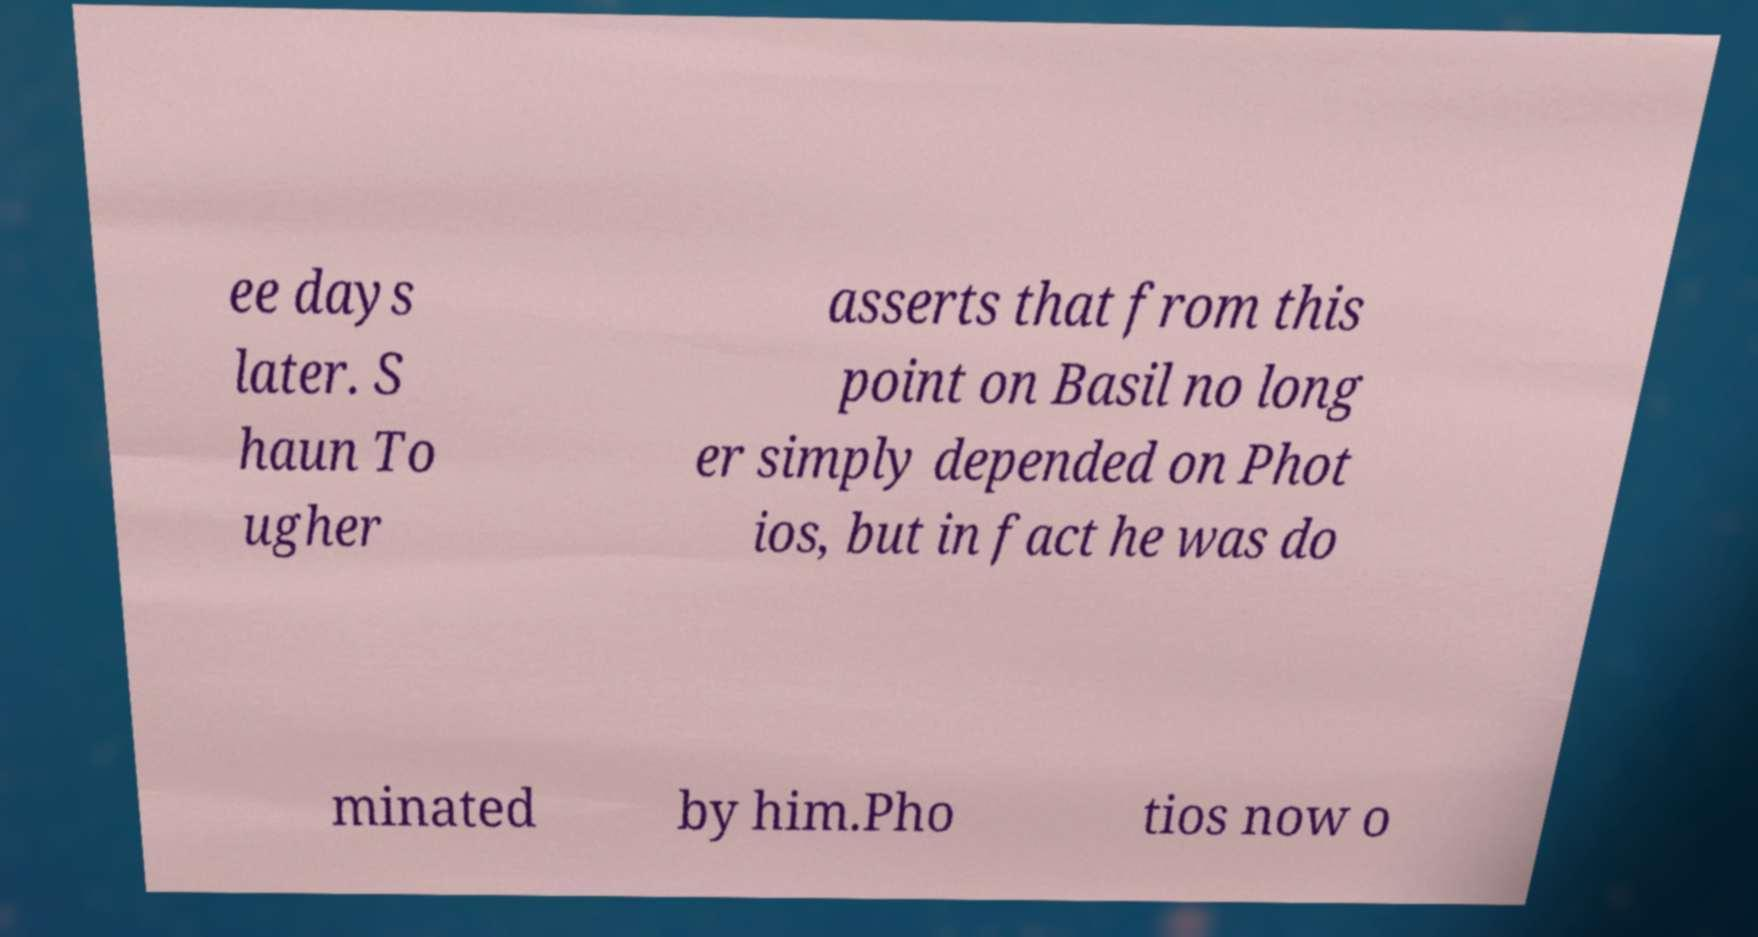Can you accurately transcribe the text from the provided image for me? ee days later. S haun To ugher asserts that from this point on Basil no long er simply depended on Phot ios, but in fact he was do minated by him.Pho tios now o 